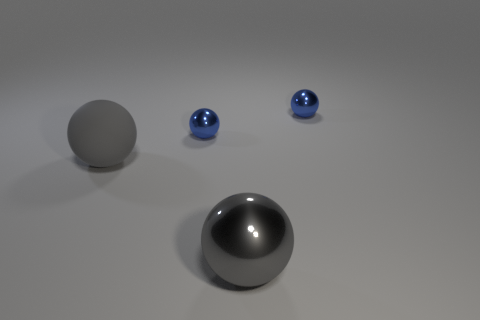What is the size of the blue metallic object on the left side of the gray ball in front of the matte ball?
Offer a terse response. Small. Is there a cyan cylinder of the same size as the gray metallic ball?
Offer a very short reply. No. There is a metallic object in front of the gray matte object; is it the same size as the gray sphere left of the gray shiny object?
Your answer should be very brief. Yes. What is the shape of the gray thing behind the big gray thing that is on the right side of the big gray rubber ball?
Keep it short and to the point. Sphere. There is a big gray matte ball; what number of gray rubber spheres are on the left side of it?
Your response must be concise. 0. Is the size of the gray matte ball the same as the gray object in front of the large matte object?
Give a very brief answer. Yes. There is a object that is in front of the gray object that is behind the big gray thing to the right of the gray matte object; what size is it?
Offer a terse response. Large. How many metal things are either tiny things or balls?
Keep it short and to the point. 3. What color is the tiny ball on the right side of the big shiny object?
Your answer should be very brief. Blue. What is the shape of the other gray object that is the same size as the gray rubber thing?
Make the answer very short. Sphere. 